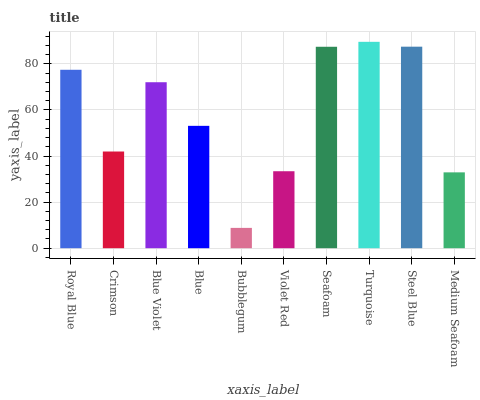Is Crimson the minimum?
Answer yes or no. No. Is Crimson the maximum?
Answer yes or no. No. Is Royal Blue greater than Crimson?
Answer yes or no. Yes. Is Crimson less than Royal Blue?
Answer yes or no. Yes. Is Crimson greater than Royal Blue?
Answer yes or no. No. Is Royal Blue less than Crimson?
Answer yes or no. No. Is Blue Violet the high median?
Answer yes or no. Yes. Is Blue the low median?
Answer yes or no. Yes. Is Medium Seafoam the high median?
Answer yes or no. No. Is Bubblegum the low median?
Answer yes or no. No. 